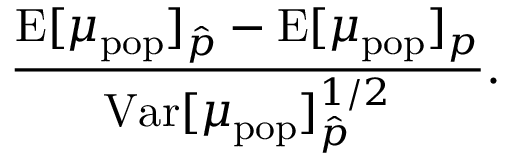Convert formula to latex. <formula><loc_0><loc_0><loc_500><loc_500>\frac { E [ \mu _ { p o p } ] _ { \hat { p } } - E [ \mu _ { p o p } ] _ { p } } { V a r [ \mu _ { p o p } ] _ { \hat { p } } ^ { 1 / 2 } } .</formula> 